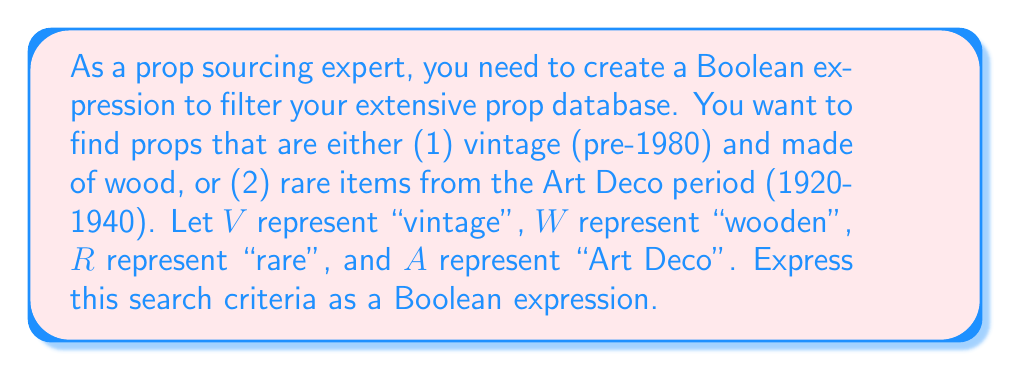What is the answer to this math problem? Let's break this down step-by-step:

1) First, let's consider the two main criteria:
   a) Vintage (pre-1980) and made of wood
   b) Rare items from the Art Deco period

2) For criterion (a), we need both conditions to be true:
   $V \wedge W$

3) For criterion (b), we need both conditions to be true:
   $R \wedge A$

4) We want items that satisfy either criterion (a) OR criterion (b). In Boolean algebra, this is represented by the OR operator $\vee$

5) Therefore, our final expression combines these two parts with OR:
   $(V \wedge W) \vee (R \wedge A)$

This Boolean expression will filter the prop database to show items that are either vintage wooden props or rare Art Deco items.
Answer: $(V \wedge W) \vee (R \wedge A)$ 